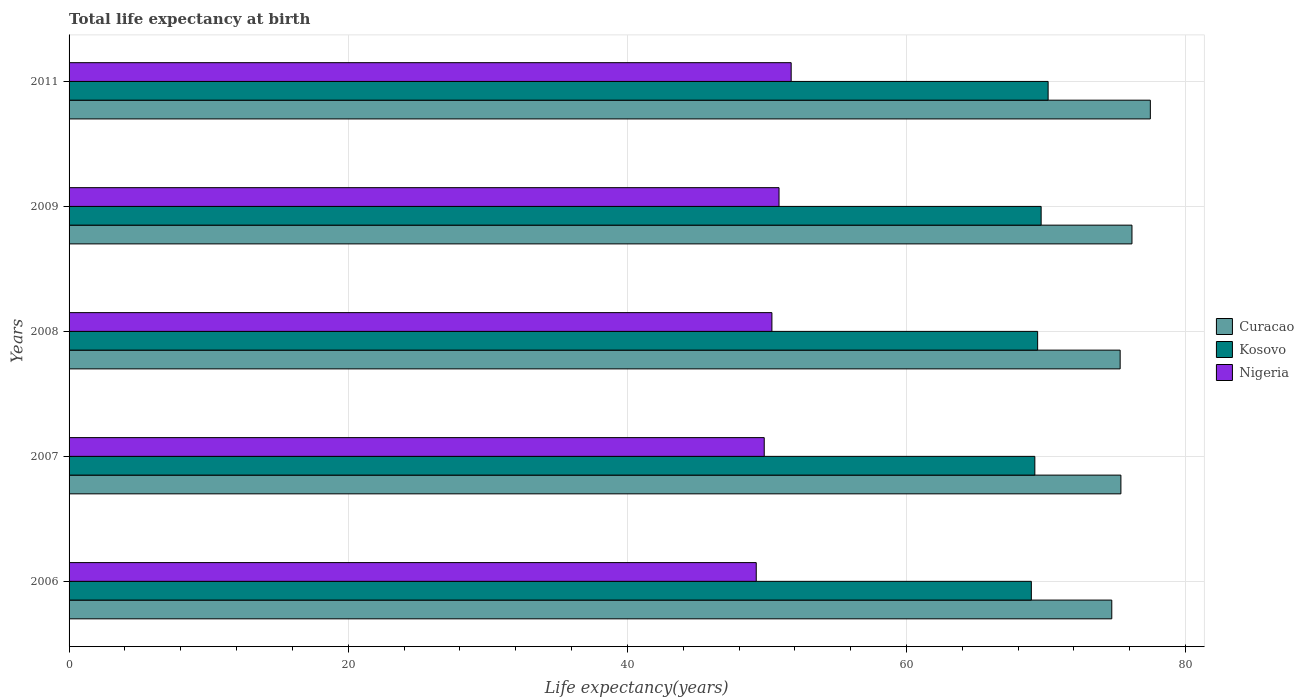How many different coloured bars are there?
Your answer should be compact. 3. Are the number of bars per tick equal to the number of legend labels?
Keep it short and to the point. Yes. Are the number of bars on each tick of the Y-axis equal?
Your response must be concise. Yes. How many bars are there on the 5th tick from the bottom?
Ensure brevity in your answer.  3. What is the life expectancy at birth in in Kosovo in 2009?
Your answer should be compact. 69.65. Across all years, what is the maximum life expectancy at birth in in Nigeria?
Your response must be concise. 51.74. Across all years, what is the minimum life expectancy at birth in in Nigeria?
Give a very brief answer. 49.24. What is the total life expectancy at birth in in Nigeria in the graph?
Your answer should be compact. 252.01. What is the difference between the life expectancy at birth in in Curacao in 2008 and that in 2009?
Make the answer very short. -0.85. What is the difference between the life expectancy at birth in in Curacao in 2006 and the life expectancy at birth in in Nigeria in 2007?
Offer a very short reply. 24.9. What is the average life expectancy at birth in in Nigeria per year?
Offer a terse response. 50.4. In the year 2011, what is the difference between the life expectancy at birth in in Nigeria and life expectancy at birth in in Curacao?
Keep it short and to the point. -25.74. In how many years, is the life expectancy at birth in in Kosovo greater than 32 years?
Offer a very short reply. 5. What is the ratio of the life expectancy at birth in in Nigeria in 2006 to that in 2007?
Your answer should be compact. 0.99. Is the life expectancy at birth in in Kosovo in 2009 less than that in 2011?
Your answer should be very brief. Yes. Is the difference between the life expectancy at birth in in Nigeria in 2006 and 2011 greater than the difference between the life expectancy at birth in in Curacao in 2006 and 2011?
Keep it short and to the point. Yes. What is the difference between the highest and the second highest life expectancy at birth in in Curacao?
Provide a succinct answer. 1.32. What is the difference between the highest and the lowest life expectancy at birth in in Kosovo?
Offer a terse response. 1.2. Is the sum of the life expectancy at birth in in Kosovo in 2006 and 2007 greater than the maximum life expectancy at birth in in Nigeria across all years?
Your answer should be compact. Yes. What does the 3rd bar from the top in 2009 represents?
Your answer should be very brief. Curacao. What does the 1st bar from the bottom in 2008 represents?
Your answer should be compact. Curacao. Is it the case that in every year, the sum of the life expectancy at birth in in Curacao and life expectancy at birth in in Nigeria is greater than the life expectancy at birth in in Kosovo?
Provide a short and direct response. Yes. How many bars are there?
Provide a short and direct response. 15. Are all the bars in the graph horizontal?
Provide a succinct answer. Yes. How many years are there in the graph?
Provide a succinct answer. 5. Does the graph contain grids?
Offer a terse response. Yes. What is the title of the graph?
Keep it short and to the point. Total life expectancy at birth. Does "Botswana" appear as one of the legend labels in the graph?
Your answer should be compact. No. What is the label or title of the X-axis?
Make the answer very short. Life expectancy(years). What is the label or title of the Y-axis?
Offer a very short reply. Years. What is the Life expectancy(years) in Curacao in 2006?
Keep it short and to the point. 74.71. What is the Life expectancy(years) of Kosovo in 2006?
Your response must be concise. 68.95. What is the Life expectancy(years) in Nigeria in 2006?
Your response must be concise. 49.24. What is the Life expectancy(years) of Curacao in 2007?
Make the answer very short. 75.36. What is the Life expectancy(years) in Kosovo in 2007?
Offer a very short reply. 69.2. What is the Life expectancy(years) in Nigeria in 2007?
Your response must be concise. 49.81. What is the Life expectancy(years) of Curacao in 2008?
Give a very brief answer. 75.31. What is the Life expectancy(years) in Kosovo in 2008?
Provide a short and direct response. 69.4. What is the Life expectancy(years) in Nigeria in 2008?
Provide a succinct answer. 50.36. What is the Life expectancy(years) of Curacao in 2009?
Make the answer very short. 76.16. What is the Life expectancy(years) in Kosovo in 2009?
Give a very brief answer. 69.65. What is the Life expectancy(years) of Nigeria in 2009?
Provide a short and direct response. 50.87. What is the Life expectancy(years) in Curacao in 2011?
Provide a succinct answer. 77.47. What is the Life expectancy(years) of Kosovo in 2011?
Provide a succinct answer. 70.15. What is the Life expectancy(years) of Nigeria in 2011?
Ensure brevity in your answer.  51.74. Across all years, what is the maximum Life expectancy(years) in Curacao?
Provide a short and direct response. 77.47. Across all years, what is the maximum Life expectancy(years) of Kosovo?
Make the answer very short. 70.15. Across all years, what is the maximum Life expectancy(years) of Nigeria?
Offer a terse response. 51.74. Across all years, what is the minimum Life expectancy(years) in Curacao?
Ensure brevity in your answer.  74.71. Across all years, what is the minimum Life expectancy(years) of Kosovo?
Your answer should be compact. 68.95. Across all years, what is the minimum Life expectancy(years) of Nigeria?
Offer a terse response. 49.24. What is the total Life expectancy(years) in Curacao in the graph?
Your response must be concise. 379.01. What is the total Life expectancy(years) of Kosovo in the graph?
Your answer should be compact. 347.34. What is the total Life expectancy(years) of Nigeria in the graph?
Your response must be concise. 252.01. What is the difference between the Life expectancy(years) in Curacao in 2006 and that in 2007?
Offer a very short reply. -0.65. What is the difference between the Life expectancy(years) of Kosovo in 2006 and that in 2007?
Provide a succinct answer. -0.25. What is the difference between the Life expectancy(years) in Nigeria in 2006 and that in 2007?
Provide a succinct answer. -0.57. What is the difference between the Life expectancy(years) of Kosovo in 2006 and that in 2008?
Provide a succinct answer. -0.45. What is the difference between the Life expectancy(years) of Nigeria in 2006 and that in 2008?
Your response must be concise. -1.12. What is the difference between the Life expectancy(years) of Curacao in 2006 and that in 2009?
Your answer should be compact. -1.45. What is the difference between the Life expectancy(years) of Kosovo in 2006 and that in 2009?
Your answer should be compact. -0.7. What is the difference between the Life expectancy(years) in Nigeria in 2006 and that in 2009?
Offer a terse response. -1.63. What is the difference between the Life expectancy(years) in Curacao in 2006 and that in 2011?
Offer a terse response. -2.76. What is the difference between the Life expectancy(years) in Kosovo in 2006 and that in 2011?
Your answer should be compact. -1.2. What is the difference between the Life expectancy(years) in Nigeria in 2006 and that in 2011?
Ensure brevity in your answer.  -2.5. What is the difference between the Life expectancy(years) of Curacao in 2007 and that in 2008?
Offer a very short reply. 0.05. What is the difference between the Life expectancy(years) of Kosovo in 2007 and that in 2008?
Give a very brief answer. -0.2. What is the difference between the Life expectancy(years) of Nigeria in 2007 and that in 2008?
Your answer should be compact. -0.55. What is the difference between the Life expectancy(years) of Curacao in 2007 and that in 2009?
Provide a short and direct response. -0.79. What is the difference between the Life expectancy(years) in Kosovo in 2007 and that in 2009?
Make the answer very short. -0.45. What is the difference between the Life expectancy(years) of Nigeria in 2007 and that in 2009?
Provide a succinct answer. -1.06. What is the difference between the Life expectancy(years) in Curacao in 2007 and that in 2011?
Provide a succinct answer. -2.11. What is the difference between the Life expectancy(years) in Kosovo in 2007 and that in 2011?
Your answer should be compact. -0.95. What is the difference between the Life expectancy(years) in Nigeria in 2007 and that in 2011?
Provide a short and direct response. -1.93. What is the difference between the Life expectancy(years) of Curacao in 2008 and that in 2009?
Provide a short and direct response. -0.85. What is the difference between the Life expectancy(years) in Kosovo in 2008 and that in 2009?
Your response must be concise. -0.25. What is the difference between the Life expectancy(years) in Nigeria in 2008 and that in 2009?
Provide a short and direct response. -0.51. What is the difference between the Life expectancy(years) of Curacao in 2008 and that in 2011?
Make the answer very short. -2.16. What is the difference between the Life expectancy(years) of Kosovo in 2008 and that in 2011?
Provide a short and direct response. -0.75. What is the difference between the Life expectancy(years) in Nigeria in 2008 and that in 2011?
Ensure brevity in your answer.  -1.38. What is the difference between the Life expectancy(years) in Curacao in 2009 and that in 2011?
Provide a succinct answer. -1.32. What is the difference between the Life expectancy(years) of Nigeria in 2009 and that in 2011?
Your answer should be very brief. -0.87. What is the difference between the Life expectancy(years) in Curacao in 2006 and the Life expectancy(years) in Kosovo in 2007?
Your response must be concise. 5.51. What is the difference between the Life expectancy(years) in Curacao in 2006 and the Life expectancy(years) in Nigeria in 2007?
Offer a terse response. 24.9. What is the difference between the Life expectancy(years) of Kosovo in 2006 and the Life expectancy(years) of Nigeria in 2007?
Your answer should be very brief. 19.14. What is the difference between the Life expectancy(years) in Curacao in 2006 and the Life expectancy(years) in Kosovo in 2008?
Offer a terse response. 5.31. What is the difference between the Life expectancy(years) of Curacao in 2006 and the Life expectancy(years) of Nigeria in 2008?
Give a very brief answer. 24.35. What is the difference between the Life expectancy(years) of Kosovo in 2006 and the Life expectancy(years) of Nigeria in 2008?
Keep it short and to the point. 18.59. What is the difference between the Life expectancy(years) in Curacao in 2006 and the Life expectancy(years) in Kosovo in 2009?
Your answer should be very brief. 5.06. What is the difference between the Life expectancy(years) of Curacao in 2006 and the Life expectancy(years) of Nigeria in 2009?
Provide a succinct answer. 23.84. What is the difference between the Life expectancy(years) of Kosovo in 2006 and the Life expectancy(years) of Nigeria in 2009?
Give a very brief answer. 18.08. What is the difference between the Life expectancy(years) in Curacao in 2006 and the Life expectancy(years) in Kosovo in 2011?
Your answer should be compact. 4.56. What is the difference between the Life expectancy(years) of Curacao in 2006 and the Life expectancy(years) of Nigeria in 2011?
Provide a short and direct response. 22.97. What is the difference between the Life expectancy(years) of Kosovo in 2006 and the Life expectancy(years) of Nigeria in 2011?
Offer a very short reply. 17.21. What is the difference between the Life expectancy(years) in Curacao in 2007 and the Life expectancy(years) in Kosovo in 2008?
Offer a terse response. 5.97. What is the difference between the Life expectancy(years) of Curacao in 2007 and the Life expectancy(years) of Nigeria in 2008?
Make the answer very short. 25.01. What is the difference between the Life expectancy(years) in Kosovo in 2007 and the Life expectancy(years) in Nigeria in 2008?
Ensure brevity in your answer.  18.84. What is the difference between the Life expectancy(years) of Curacao in 2007 and the Life expectancy(years) of Kosovo in 2009?
Make the answer very short. 5.71. What is the difference between the Life expectancy(years) in Curacao in 2007 and the Life expectancy(years) in Nigeria in 2009?
Your answer should be very brief. 24.49. What is the difference between the Life expectancy(years) in Kosovo in 2007 and the Life expectancy(years) in Nigeria in 2009?
Your answer should be very brief. 18.33. What is the difference between the Life expectancy(years) of Curacao in 2007 and the Life expectancy(years) of Kosovo in 2011?
Keep it short and to the point. 5.21. What is the difference between the Life expectancy(years) in Curacao in 2007 and the Life expectancy(years) in Nigeria in 2011?
Your response must be concise. 23.63. What is the difference between the Life expectancy(years) of Kosovo in 2007 and the Life expectancy(years) of Nigeria in 2011?
Your response must be concise. 17.46. What is the difference between the Life expectancy(years) of Curacao in 2008 and the Life expectancy(years) of Kosovo in 2009?
Provide a succinct answer. 5.66. What is the difference between the Life expectancy(years) in Curacao in 2008 and the Life expectancy(years) in Nigeria in 2009?
Offer a terse response. 24.44. What is the difference between the Life expectancy(years) in Kosovo in 2008 and the Life expectancy(years) in Nigeria in 2009?
Offer a very short reply. 18.53. What is the difference between the Life expectancy(years) in Curacao in 2008 and the Life expectancy(years) in Kosovo in 2011?
Keep it short and to the point. 5.16. What is the difference between the Life expectancy(years) of Curacao in 2008 and the Life expectancy(years) of Nigeria in 2011?
Ensure brevity in your answer.  23.57. What is the difference between the Life expectancy(years) of Kosovo in 2008 and the Life expectancy(years) of Nigeria in 2011?
Offer a very short reply. 17.66. What is the difference between the Life expectancy(years) in Curacao in 2009 and the Life expectancy(years) in Kosovo in 2011?
Provide a short and direct response. 6.01. What is the difference between the Life expectancy(years) in Curacao in 2009 and the Life expectancy(years) in Nigeria in 2011?
Provide a short and direct response. 24.42. What is the difference between the Life expectancy(years) in Kosovo in 2009 and the Life expectancy(years) in Nigeria in 2011?
Provide a succinct answer. 17.91. What is the average Life expectancy(years) of Curacao per year?
Give a very brief answer. 75.8. What is the average Life expectancy(years) in Kosovo per year?
Your answer should be compact. 69.47. What is the average Life expectancy(years) in Nigeria per year?
Your answer should be compact. 50.4. In the year 2006, what is the difference between the Life expectancy(years) in Curacao and Life expectancy(years) in Kosovo?
Provide a succinct answer. 5.76. In the year 2006, what is the difference between the Life expectancy(years) of Curacao and Life expectancy(years) of Nigeria?
Offer a terse response. 25.47. In the year 2006, what is the difference between the Life expectancy(years) of Kosovo and Life expectancy(years) of Nigeria?
Provide a short and direct response. 19.71. In the year 2007, what is the difference between the Life expectancy(years) in Curacao and Life expectancy(years) in Kosovo?
Ensure brevity in your answer.  6.17. In the year 2007, what is the difference between the Life expectancy(years) in Curacao and Life expectancy(years) in Nigeria?
Offer a terse response. 25.56. In the year 2007, what is the difference between the Life expectancy(years) of Kosovo and Life expectancy(years) of Nigeria?
Your answer should be compact. 19.39. In the year 2008, what is the difference between the Life expectancy(years) of Curacao and Life expectancy(years) of Kosovo?
Offer a terse response. 5.91. In the year 2008, what is the difference between the Life expectancy(years) in Curacao and Life expectancy(years) in Nigeria?
Your answer should be compact. 24.95. In the year 2008, what is the difference between the Life expectancy(years) in Kosovo and Life expectancy(years) in Nigeria?
Provide a succinct answer. 19.04. In the year 2009, what is the difference between the Life expectancy(years) in Curacao and Life expectancy(years) in Kosovo?
Offer a very short reply. 6.51. In the year 2009, what is the difference between the Life expectancy(years) in Curacao and Life expectancy(years) in Nigeria?
Your answer should be compact. 25.29. In the year 2009, what is the difference between the Life expectancy(years) of Kosovo and Life expectancy(years) of Nigeria?
Your answer should be compact. 18.78. In the year 2011, what is the difference between the Life expectancy(years) of Curacao and Life expectancy(years) of Kosovo?
Your answer should be very brief. 7.32. In the year 2011, what is the difference between the Life expectancy(years) in Curacao and Life expectancy(years) in Nigeria?
Offer a terse response. 25.74. In the year 2011, what is the difference between the Life expectancy(years) of Kosovo and Life expectancy(years) of Nigeria?
Make the answer very short. 18.41. What is the ratio of the Life expectancy(years) of Kosovo in 2006 to that in 2007?
Your answer should be very brief. 1. What is the ratio of the Life expectancy(years) of Kosovo in 2006 to that in 2008?
Provide a short and direct response. 0.99. What is the ratio of the Life expectancy(years) in Nigeria in 2006 to that in 2008?
Offer a terse response. 0.98. What is the ratio of the Life expectancy(years) in Nigeria in 2006 to that in 2009?
Offer a terse response. 0.97. What is the ratio of the Life expectancy(years) in Curacao in 2006 to that in 2011?
Keep it short and to the point. 0.96. What is the ratio of the Life expectancy(years) of Kosovo in 2006 to that in 2011?
Give a very brief answer. 0.98. What is the ratio of the Life expectancy(years) in Nigeria in 2006 to that in 2011?
Ensure brevity in your answer.  0.95. What is the ratio of the Life expectancy(years) in Kosovo in 2007 to that in 2008?
Keep it short and to the point. 1. What is the ratio of the Life expectancy(years) of Nigeria in 2007 to that in 2008?
Provide a succinct answer. 0.99. What is the ratio of the Life expectancy(years) of Kosovo in 2007 to that in 2009?
Make the answer very short. 0.99. What is the ratio of the Life expectancy(years) of Nigeria in 2007 to that in 2009?
Provide a succinct answer. 0.98. What is the ratio of the Life expectancy(years) of Curacao in 2007 to that in 2011?
Give a very brief answer. 0.97. What is the ratio of the Life expectancy(years) in Kosovo in 2007 to that in 2011?
Offer a very short reply. 0.99. What is the ratio of the Life expectancy(years) in Nigeria in 2007 to that in 2011?
Your answer should be compact. 0.96. What is the ratio of the Life expectancy(years) in Curacao in 2008 to that in 2009?
Offer a terse response. 0.99. What is the ratio of the Life expectancy(years) in Nigeria in 2008 to that in 2009?
Give a very brief answer. 0.99. What is the ratio of the Life expectancy(years) of Curacao in 2008 to that in 2011?
Give a very brief answer. 0.97. What is the ratio of the Life expectancy(years) of Kosovo in 2008 to that in 2011?
Offer a terse response. 0.99. What is the ratio of the Life expectancy(years) in Nigeria in 2008 to that in 2011?
Keep it short and to the point. 0.97. What is the ratio of the Life expectancy(years) in Curacao in 2009 to that in 2011?
Provide a succinct answer. 0.98. What is the ratio of the Life expectancy(years) of Nigeria in 2009 to that in 2011?
Your answer should be very brief. 0.98. What is the difference between the highest and the second highest Life expectancy(years) in Curacao?
Provide a short and direct response. 1.32. What is the difference between the highest and the second highest Life expectancy(years) of Kosovo?
Your response must be concise. 0.5. What is the difference between the highest and the second highest Life expectancy(years) of Nigeria?
Give a very brief answer. 0.87. What is the difference between the highest and the lowest Life expectancy(years) of Curacao?
Make the answer very short. 2.76. What is the difference between the highest and the lowest Life expectancy(years) in Kosovo?
Your answer should be compact. 1.2. What is the difference between the highest and the lowest Life expectancy(years) of Nigeria?
Provide a short and direct response. 2.5. 